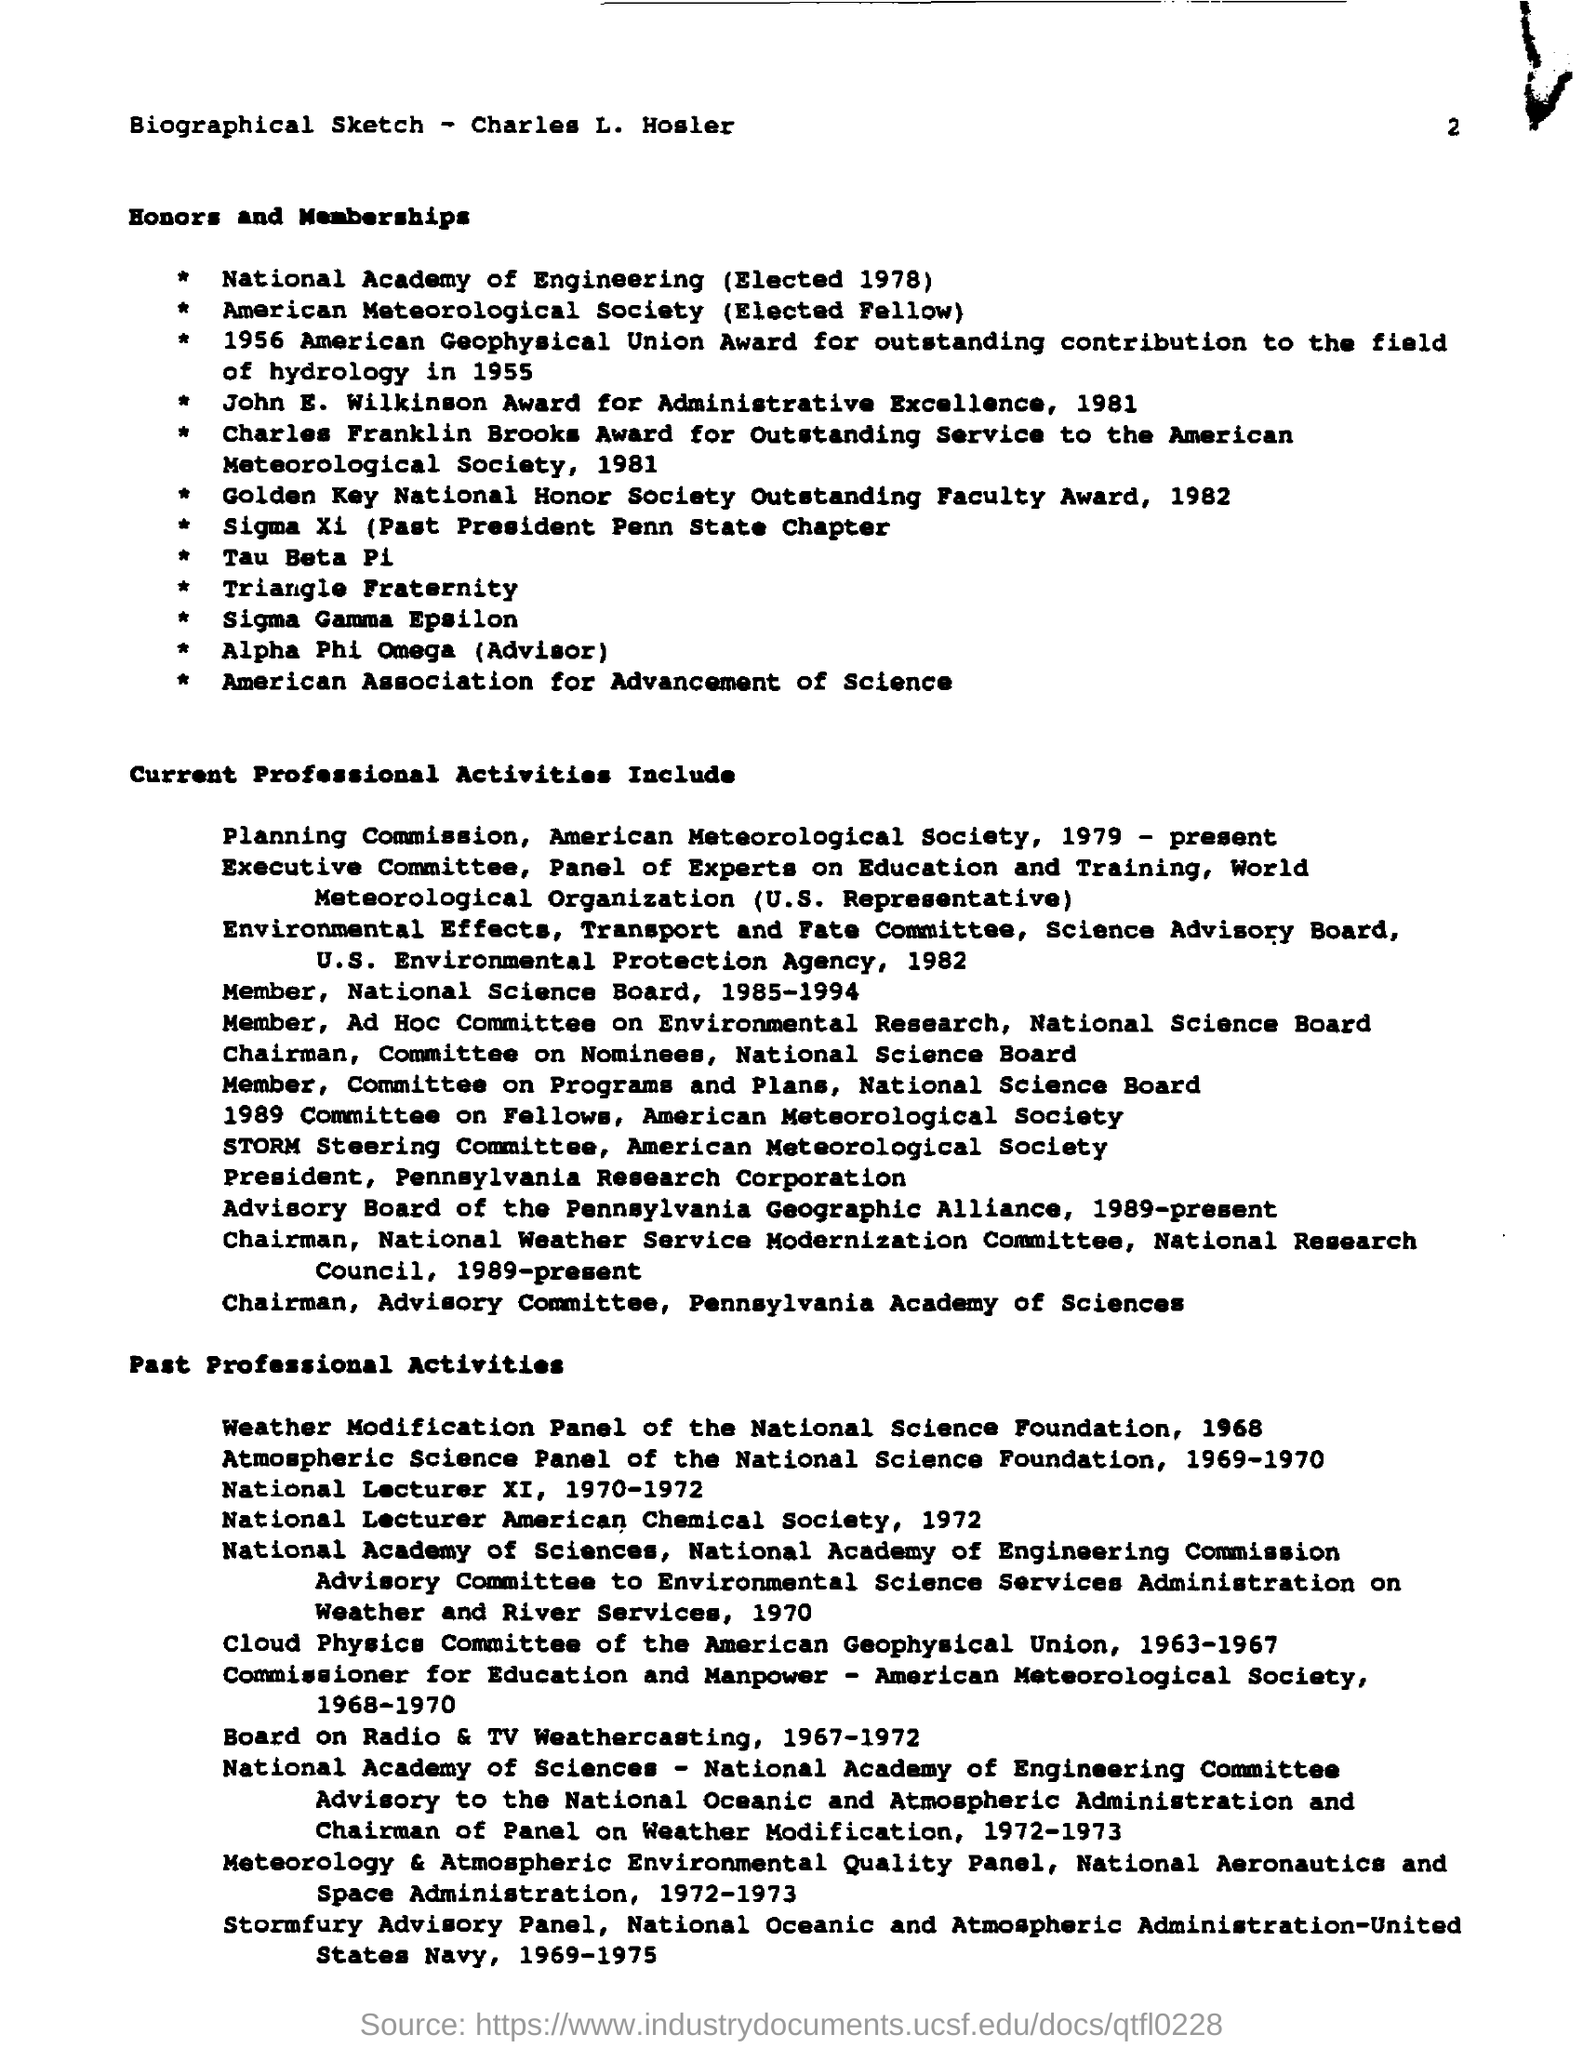Give some essential details in this illustration. The biographical sketch of Charles L. Hosler is presented here. On October 11, 1978, Charles L. Hosler was elected to the National Academy of Engineering. The document is about the biography of Charles L. Hosler. In 1955, Charles received the American Geophysical Union Award for his outstanding contribution to the field of hydrology. 